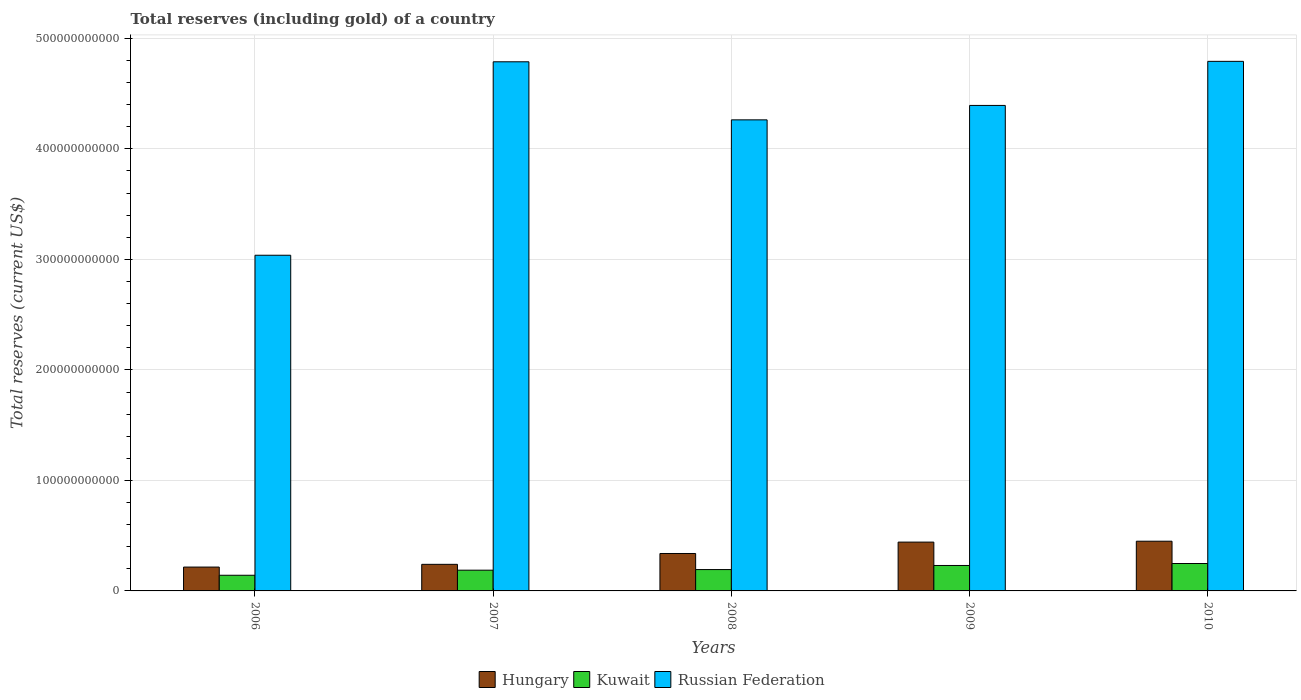How many different coloured bars are there?
Make the answer very short. 3. How many groups of bars are there?
Offer a very short reply. 5. Are the number of bars per tick equal to the number of legend labels?
Provide a succinct answer. Yes. Are the number of bars on each tick of the X-axis equal?
Provide a succinct answer. Yes. How many bars are there on the 3rd tick from the left?
Your answer should be compact. 3. How many bars are there on the 5th tick from the right?
Your answer should be very brief. 3. What is the label of the 3rd group of bars from the left?
Make the answer very short. 2008. In how many cases, is the number of bars for a given year not equal to the number of legend labels?
Offer a very short reply. 0. What is the total reserves (including gold) in Kuwait in 2008?
Offer a very short reply. 1.93e+1. Across all years, what is the maximum total reserves (including gold) in Hungary?
Provide a succinct answer. 4.50e+1. Across all years, what is the minimum total reserves (including gold) in Kuwait?
Ensure brevity in your answer.  1.42e+1. In which year was the total reserves (including gold) in Hungary maximum?
Give a very brief answer. 2010. What is the total total reserves (including gold) in Kuwait in the graph?
Provide a succinct answer. 1.00e+11. What is the difference between the total reserves (including gold) in Hungary in 2007 and that in 2010?
Offer a terse response. -2.09e+1. What is the difference between the total reserves (including gold) in Kuwait in 2007 and the total reserves (including gold) in Hungary in 2009?
Your answer should be very brief. -2.54e+1. What is the average total reserves (including gold) in Kuwait per year?
Make the answer very short. 2.00e+1. In the year 2010, what is the difference between the total reserves (including gold) in Hungary and total reserves (including gold) in Russian Federation?
Ensure brevity in your answer.  -4.34e+11. What is the ratio of the total reserves (including gold) in Kuwait in 2008 to that in 2009?
Keep it short and to the point. 0.84. Is the total reserves (including gold) in Russian Federation in 2007 less than that in 2010?
Keep it short and to the point. Yes. What is the difference between the highest and the second highest total reserves (including gold) in Hungary?
Make the answer very short. 8.07e+08. What is the difference between the highest and the lowest total reserves (including gold) in Russian Federation?
Your answer should be very brief. 1.75e+11. In how many years, is the total reserves (including gold) in Kuwait greater than the average total reserves (including gold) in Kuwait taken over all years?
Provide a short and direct response. 2. What does the 1st bar from the left in 2010 represents?
Ensure brevity in your answer.  Hungary. What does the 3rd bar from the right in 2007 represents?
Your answer should be very brief. Hungary. Is it the case that in every year, the sum of the total reserves (including gold) in Kuwait and total reserves (including gold) in Russian Federation is greater than the total reserves (including gold) in Hungary?
Offer a very short reply. Yes. How many bars are there?
Provide a succinct answer. 15. Are all the bars in the graph horizontal?
Offer a terse response. No. How many years are there in the graph?
Your answer should be very brief. 5. What is the difference between two consecutive major ticks on the Y-axis?
Provide a short and direct response. 1.00e+11. Does the graph contain any zero values?
Keep it short and to the point. No. Does the graph contain grids?
Offer a very short reply. Yes. How many legend labels are there?
Offer a very short reply. 3. What is the title of the graph?
Keep it short and to the point. Total reserves (including gold) of a country. What is the label or title of the Y-axis?
Keep it short and to the point. Total reserves (current US$). What is the Total reserves (current US$) of Hungary in 2006?
Give a very brief answer. 2.16e+1. What is the Total reserves (current US$) of Kuwait in 2006?
Offer a very short reply. 1.42e+1. What is the Total reserves (current US$) of Russian Federation in 2006?
Your answer should be compact. 3.04e+11. What is the Total reserves (current US$) of Hungary in 2007?
Offer a very short reply. 2.41e+1. What is the Total reserves (current US$) in Kuwait in 2007?
Provide a short and direct response. 1.88e+1. What is the Total reserves (current US$) in Russian Federation in 2007?
Ensure brevity in your answer.  4.79e+11. What is the Total reserves (current US$) of Hungary in 2008?
Offer a very short reply. 3.39e+1. What is the Total reserves (current US$) in Kuwait in 2008?
Your answer should be very brief. 1.93e+1. What is the Total reserves (current US$) of Russian Federation in 2008?
Offer a terse response. 4.26e+11. What is the Total reserves (current US$) in Hungary in 2009?
Provide a succinct answer. 4.42e+1. What is the Total reserves (current US$) in Kuwait in 2009?
Offer a terse response. 2.30e+1. What is the Total reserves (current US$) of Russian Federation in 2009?
Your answer should be compact. 4.39e+11. What is the Total reserves (current US$) in Hungary in 2010?
Ensure brevity in your answer.  4.50e+1. What is the Total reserves (current US$) in Kuwait in 2010?
Your answer should be compact. 2.48e+1. What is the Total reserves (current US$) in Russian Federation in 2010?
Offer a very short reply. 4.79e+11. Across all years, what is the maximum Total reserves (current US$) in Hungary?
Keep it short and to the point. 4.50e+1. Across all years, what is the maximum Total reserves (current US$) in Kuwait?
Provide a short and direct response. 2.48e+1. Across all years, what is the maximum Total reserves (current US$) of Russian Federation?
Give a very brief answer. 4.79e+11. Across all years, what is the minimum Total reserves (current US$) of Hungary?
Give a very brief answer. 2.16e+1. Across all years, what is the minimum Total reserves (current US$) of Kuwait?
Your answer should be very brief. 1.42e+1. Across all years, what is the minimum Total reserves (current US$) of Russian Federation?
Your answer should be compact. 3.04e+11. What is the total Total reserves (current US$) of Hungary in the graph?
Provide a succinct answer. 1.69e+11. What is the total Total reserves (current US$) of Kuwait in the graph?
Keep it short and to the point. 1.00e+11. What is the total Total reserves (current US$) in Russian Federation in the graph?
Give a very brief answer. 2.13e+12. What is the difference between the Total reserves (current US$) of Hungary in 2006 and that in 2007?
Offer a terse response. -2.46e+09. What is the difference between the Total reserves (current US$) in Kuwait in 2006 and that in 2007?
Offer a very short reply. -4.60e+09. What is the difference between the Total reserves (current US$) in Russian Federation in 2006 and that in 2007?
Your answer should be very brief. -1.75e+11. What is the difference between the Total reserves (current US$) in Hungary in 2006 and that in 2008?
Offer a terse response. -1.23e+1. What is the difference between the Total reserves (current US$) of Kuwait in 2006 and that in 2008?
Provide a short and direct response. -5.14e+09. What is the difference between the Total reserves (current US$) of Russian Federation in 2006 and that in 2008?
Offer a very short reply. -1.23e+11. What is the difference between the Total reserves (current US$) in Hungary in 2006 and that in 2009?
Your answer should be compact. -2.26e+1. What is the difference between the Total reserves (current US$) in Kuwait in 2006 and that in 2009?
Your answer should be very brief. -8.85e+09. What is the difference between the Total reserves (current US$) of Russian Federation in 2006 and that in 2009?
Your answer should be compact. -1.36e+11. What is the difference between the Total reserves (current US$) of Hungary in 2006 and that in 2010?
Provide a short and direct response. -2.34e+1. What is the difference between the Total reserves (current US$) in Kuwait in 2006 and that in 2010?
Give a very brief answer. -1.06e+1. What is the difference between the Total reserves (current US$) in Russian Federation in 2006 and that in 2010?
Provide a short and direct response. -1.75e+11. What is the difference between the Total reserves (current US$) of Hungary in 2007 and that in 2008?
Provide a short and direct response. -9.82e+09. What is the difference between the Total reserves (current US$) of Kuwait in 2007 and that in 2008?
Your response must be concise. -5.44e+08. What is the difference between the Total reserves (current US$) in Russian Federation in 2007 and that in 2008?
Ensure brevity in your answer.  5.25e+1. What is the difference between the Total reserves (current US$) of Hungary in 2007 and that in 2009?
Offer a very short reply. -2.01e+1. What is the difference between the Total reserves (current US$) in Kuwait in 2007 and that in 2009?
Your response must be concise. -4.25e+09. What is the difference between the Total reserves (current US$) of Russian Federation in 2007 and that in 2009?
Provide a short and direct response. 3.95e+1. What is the difference between the Total reserves (current US$) in Hungary in 2007 and that in 2010?
Provide a succinct answer. -2.09e+1. What is the difference between the Total reserves (current US$) of Kuwait in 2007 and that in 2010?
Provide a succinct answer. -6.03e+09. What is the difference between the Total reserves (current US$) in Russian Federation in 2007 and that in 2010?
Make the answer very short. -4.00e+08. What is the difference between the Total reserves (current US$) of Hungary in 2008 and that in 2009?
Your answer should be compact. -1.03e+1. What is the difference between the Total reserves (current US$) in Kuwait in 2008 and that in 2009?
Provide a short and direct response. -3.71e+09. What is the difference between the Total reserves (current US$) of Russian Federation in 2008 and that in 2009?
Give a very brief answer. -1.31e+1. What is the difference between the Total reserves (current US$) in Hungary in 2008 and that in 2010?
Provide a succinct answer. -1.11e+1. What is the difference between the Total reserves (current US$) in Kuwait in 2008 and that in 2010?
Keep it short and to the point. -5.48e+09. What is the difference between the Total reserves (current US$) in Russian Federation in 2008 and that in 2010?
Your answer should be very brief. -5.29e+1. What is the difference between the Total reserves (current US$) in Hungary in 2009 and that in 2010?
Your answer should be very brief. -8.07e+08. What is the difference between the Total reserves (current US$) in Kuwait in 2009 and that in 2010?
Provide a short and direct response. -1.78e+09. What is the difference between the Total reserves (current US$) of Russian Federation in 2009 and that in 2010?
Your response must be concise. -3.99e+1. What is the difference between the Total reserves (current US$) of Hungary in 2006 and the Total reserves (current US$) of Kuwait in 2007?
Offer a very short reply. 2.81e+09. What is the difference between the Total reserves (current US$) in Hungary in 2006 and the Total reserves (current US$) in Russian Federation in 2007?
Your response must be concise. -4.57e+11. What is the difference between the Total reserves (current US$) in Kuwait in 2006 and the Total reserves (current US$) in Russian Federation in 2007?
Ensure brevity in your answer.  -4.65e+11. What is the difference between the Total reserves (current US$) of Hungary in 2006 and the Total reserves (current US$) of Kuwait in 2008?
Make the answer very short. 2.27e+09. What is the difference between the Total reserves (current US$) of Hungary in 2006 and the Total reserves (current US$) of Russian Federation in 2008?
Your response must be concise. -4.05e+11. What is the difference between the Total reserves (current US$) in Kuwait in 2006 and the Total reserves (current US$) in Russian Federation in 2008?
Keep it short and to the point. -4.12e+11. What is the difference between the Total reserves (current US$) in Hungary in 2006 and the Total reserves (current US$) in Kuwait in 2009?
Offer a very short reply. -1.44e+09. What is the difference between the Total reserves (current US$) in Hungary in 2006 and the Total reserves (current US$) in Russian Federation in 2009?
Your response must be concise. -4.18e+11. What is the difference between the Total reserves (current US$) in Kuwait in 2006 and the Total reserves (current US$) in Russian Federation in 2009?
Your answer should be very brief. -4.25e+11. What is the difference between the Total reserves (current US$) in Hungary in 2006 and the Total reserves (current US$) in Kuwait in 2010?
Make the answer very short. -3.21e+09. What is the difference between the Total reserves (current US$) of Hungary in 2006 and the Total reserves (current US$) of Russian Federation in 2010?
Your answer should be very brief. -4.58e+11. What is the difference between the Total reserves (current US$) in Kuwait in 2006 and the Total reserves (current US$) in Russian Federation in 2010?
Your response must be concise. -4.65e+11. What is the difference between the Total reserves (current US$) of Hungary in 2007 and the Total reserves (current US$) of Kuwait in 2008?
Ensure brevity in your answer.  4.73e+09. What is the difference between the Total reserves (current US$) of Hungary in 2007 and the Total reserves (current US$) of Russian Federation in 2008?
Your answer should be compact. -4.02e+11. What is the difference between the Total reserves (current US$) in Kuwait in 2007 and the Total reserves (current US$) in Russian Federation in 2008?
Offer a very short reply. -4.08e+11. What is the difference between the Total reserves (current US$) in Hungary in 2007 and the Total reserves (current US$) in Kuwait in 2009?
Your response must be concise. 1.02e+09. What is the difference between the Total reserves (current US$) in Hungary in 2007 and the Total reserves (current US$) in Russian Federation in 2009?
Ensure brevity in your answer.  -4.15e+11. What is the difference between the Total reserves (current US$) of Kuwait in 2007 and the Total reserves (current US$) of Russian Federation in 2009?
Your response must be concise. -4.21e+11. What is the difference between the Total reserves (current US$) in Hungary in 2007 and the Total reserves (current US$) in Kuwait in 2010?
Your answer should be compact. -7.52e+08. What is the difference between the Total reserves (current US$) of Hungary in 2007 and the Total reserves (current US$) of Russian Federation in 2010?
Provide a short and direct response. -4.55e+11. What is the difference between the Total reserves (current US$) in Kuwait in 2007 and the Total reserves (current US$) in Russian Federation in 2010?
Make the answer very short. -4.60e+11. What is the difference between the Total reserves (current US$) in Hungary in 2008 and the Total reserves (current US$) in Kuwait in 2009?
Ensure brevity in your answer.  1.08e+1. What is the difference between the Total reserves (current US$) of Hungary in 2008 and the Total reserves (current US$) of Russian Federation in 2009?
Offer a very short reply. -4.05e+11. What is the difference between the Total reserves (current US$) in Kuwait in 2008 and the Total reserves (current US$) in Russian Federation in 2009?
Ensure brevity in your answer.  -4.20e+11. What is the difference between the Total reserves (current US$) of Hungary in 2008 and the Total reserves (current US$) of Kuwait in 2010?
Offer a very short reply. 9.07e+09. What is the difference between the Total reserves (current US$) in Hungary in 2008 and the Total reserves (current US$) in Russian Federation in 2010?
Your answer should be compact. -4.45e+11. What is the difference between the Total reserves (current US$) of Kuwait in 2008 and the Total reserves (current US$) of Russian Federation in 2010?
Your answer should be compact. -4.60e+11. What is the difference between the Total reserves (current US$) in Hungary in 2009 and the Total reserves (current US$) in Kuwait in 2010?
Keep it short and to the point. 1.94e+1. What is the difference between the Total reserves (current US$) of Hungary in 2009 and the Total reserves (current US$) of Russian Federation in 2010?
Offer a terse response. -4.35e+11. What is the difference between the Total reserves (current US$) in Kuwait in 2009 and the Total reserves (current US$) in Russian Federation in 2010?
Provide a succinct answer. -4.56e+11. What is the average Total reserves (current US$) in Hungary per year?
Offer a terse response. 3.37e+1. What is the average Total reserves (current US$) of Kuwait per year?
Give a very brief answer. 2.00e+1. What is the average Total reserves (current US$) of Russian Federation per year?
Your answer should be compact. 4.25e+11. In the year 2006, what is the difference between the Total reserves (current US$) of Hungary and Total reserves (current US$) of Kuwait?
Offer a very short reply. 7.41e+09. In the year 2006, what is the difference between the Total reserves (current US$) of Hungary and Total reserves (current US$) of Russian Federation?
Offer a terse response. -2.82e+11. In the year 2006, what is the difference between the Total reserves (current US$) of Kuwait and Total reserves (current US$) of Russian Federation?
Keep it short and to the point. -2.90e+11. In the year 2007, what is the difference between the Total reserves (current US$) of Hungary and Total reserves (current US$) of Kuwait?
Ensure brevity in your answer.  5.28e+09. In the year 2007, what is the difference between the Total reserves (current US$) of Hungary and Total reserves (current US$) of Russian Federation?
Your answer should be very brief. -4.55e+11. In the year 2007, what is the difference between the Total reserves (current US$) of Kuwait and Total reserves (current US$) of Russian Federation?
Keep it short and to the point. -4.60e+11. In the year 2008, what is the difference between the Total reserves (current US$) in Hungary and Total reserves (current US$) in Kuwait?
Your answer should be compact. 1.46e+1. In the year 2008, what is the difference between the Total reserves (current US$) in Hungary and Total reserves (current US$) in Russian Federation?
Provide a succinct answer. -3.92e+11. In the year 2008, what is the difference between the Total reserves (current US$) of Kuwait and Total reserves (current US$) of Russian Federation?
Your answer should be compact. -4.07e+11. In the year 2009, what is the difference between the Total reserves (current US$) in Hungary and Total reserves (current US$) in Kuwait?
Offer a very short reply. 2.12e+1. In the year 2009, what is the difference between the Total reserves (current US$) in Hungary and Total reserves (current US$) in Russian Federation?
Ensure brevity in your answer.  -3.95e+11. In the year 2009, what is the difference between the Total reserves (current US$) of Kuwait and Total reserves (current US$) of Russian Federation?
Offer a terse response. -4.16e+11. In the year 2010, what is the difference between the Total reserves (current US$) in Hungary and Total reserves (current US$) in Kuwait?
Provide a short and direct response. 2.02e+1. In the year 2010, what is the difference between the Total reserves (current US$) in Hungary and Total reserves (current US$) in Russian Federation?
Your answer should be very brief. -4.34e+11. In the year 2010, what is the difference between the Total reserves (current US$) in Kuwait and Total reserves (current US$) in Russian Federation?
Offer a very short reply. -4.54e+11. What is the ratio of the Total reserves (current US$) in Hungary in 2006 to that in 2007?
Keep it short and to the point. 0.9. What is the ratio of the Total reserves (current US$) of Kuwait in 2006 to that in 2007?
Your answer should be very brief. 0.76. What is the ratio of the Total reserves (current US$) of Russian Federation in 2006 to that in 2007?
Keep it short and to the point. 0.63. What is the ratio of the Total reserves (current US$) in Hungary in 2006 to that in 2008?
Provide a succinct answer. 0.64. What is the ratio of the Total reserves (current US$) of Kuwait in 2006 to that in 2008?
Your response must be concise. 0.73. What is the ratio of the Total reserves (current US$) of Russian Federation in 2006 to that in 2008?
Your answer should be compact. 0.71. What is the ratio of the Total reserves (current US$) in Hungary in 2006 to that in 2009?
Your answer should be compact. 0.49. What is the ratio of the Total reserves (current US$) of Kuwait in 2006 to that in 2009?
Offer a very short reply. 0.62. What is the ratio of the Total reserves (current US$) in Russian Federation in 2006 to that in 2009?
Give a very brief answer. 0.69. What is the ratio of the Total reserves (current US$) of Hungary in 2006 to that in 2010?
Your response must be concise. 0.48. What is the ratio of the Total reserves (current US$) of Kuwait in 2006 to that in 2010?
Provide a succinct answer. 0.57. What is the ratio of the Total reserves (current US$) of Russian Federation in 2006 to that in 2010?
Keep it short and to the point. 0.63. What is the ratio of the Total reserves (current US$) in Hungary in 2007 to that in 2008?
Provide a succinct answer. 0.71. What is the ratio of the Total reserves (current US$) of Kuwait in 2007 to that in 2008?
Offer a terse response. 0.97. What is the ratio of the Total reserves (current US$) in Russian Federation in 2007 to that in 2008?
Your answer should be compact. 1.12. What is the ratio of the Total reserves (current US$) in Hungary in 2007 to that in 2009?
Offer a very short reply. 0.54. What is the ratio of the Total reserves (current US$) of Kuwait in 2007 to that in 2009?
Ensure brevity in your answer.  0.82. What is the ratio of the Total reserves (current US$) in Russian Federation in 2007 to that in 2009?
Your answer should be compact. 1.09. What is the ratio of the Total reserves (current US$) in Hungary in 2007 to that in 2010?
Your answer should be compact. 0.53. What is the ratio of the Total reserves (current US$) of Kuwait in 2007 to that in 2010?
Ensure brevity in your answer.  0.76. What is the ratio of the Total reserves (current US$) of Russian Federation in 2007 to that in 2010?
Provide a succinct answer. 1. What is the ratio of the Total reserves (current US$) of Hungary in 2008 to that in 2009?
Ensure brevity in your answer.  0.77. What is the ratio of the Total reserves (current US$) in Kuwait in 2008 to that in 2009?
Offer a very short reply. 0.84. What is the ratio of the Total reserves (current US$) in Russian Federation in 2008 to that in 2009?
Make the answer very short. 0.97. What is the ratio of the Total reserves (current US$) of Hungary in 2008 to that in 2010?
Provide a short and direct response. 0.75. What is the ratio of the Total reserves (current US$) of Kuwait in 2008 to that in 2010?
Your response must be concise. 0.78. What is the ratio of the Total reserves (current US$) in Russian Federation in 2008 to that in 2010?
Offer a terse response. 0.89. What is the ratio of the Total reserves (current US$) of Hungary in 2009 to that in 2010?
Offer a very short reply. 0.98. What is the ratio of the Total reserves (current US$) of Kuwait in 2009 to that in 2010?
Give a very brief answer. 0.93. What is the ratio of the Total reserves (current US$) of Russian Federation in 2009 to that in 2010?
Your answer should be very brief. 0.92. What is the difference between the highest and the second highest Total reserves (current US$) of Hungary?
Offer a terse response. 8.07e+08. What is the difference between the highest and the second highest Total reserves (current US$) of Kuwait?
Offer a terse response. 1.78e+09. What is the difference between the highest and the second highest Total reserves (current US$) in Russian Federation?
Provide a short and direct response. 4.00e+08. What is the difference between the highest and the lowest Total reserves (current US$) of Hungary?
Your answer should be compact. 2.34e+1. What is the difference between the highest and the lowest Total reserves (current US$) in Kuwait?
Your answer should be compact. 1.06e+1. What is the difference between the highest and the lowest Total reserves (current US$) of Russian Federation?
Ensure brevity in your answer.  1.75e+11. 